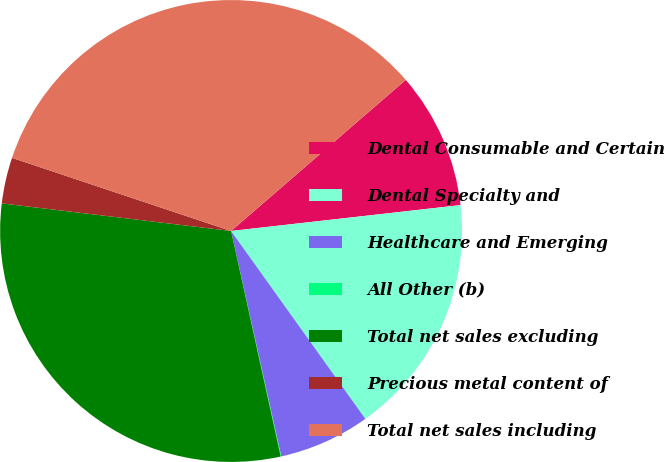<chart> <loc_0><loc_0><loc_500><loc_500><pie_chart><fcel>Dental Consumable and Certain<fcel>Dental Specialty and<fcel>Healthcare and Emerging<fcel>All Other (b)<fcel>Total net sales excluding<fcel>Precious metal content of<fcel>Total net sales including<nl><fcel>9.56%<fcel>16.91%<fcel>6.39%<fcel>0.04%<fcel>30.35%<fcel>3.22%<fcel>33.52%<nl></chart> 